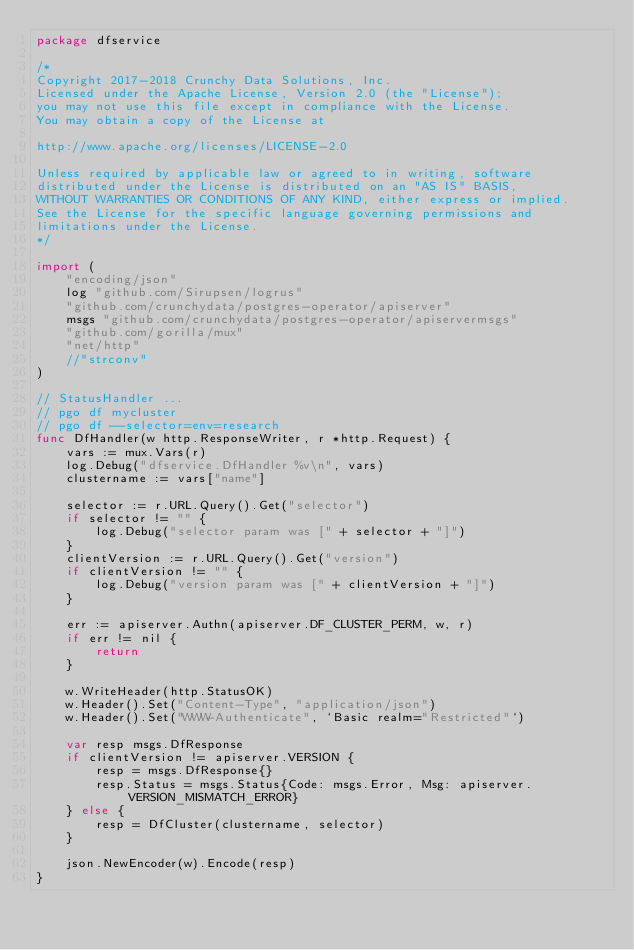<code> <loc_0><loc_0><loc_500><loc_500><_Go_>package dfservice

/*
Copyright 2017-2018 Crunchy Data Solutions, Inc.
Licensed under the Apache License, Version 2.0 (the "License");
you may not use this file except in compliance with the License.
You may obtain a copy of the License at

http://www.apache.org/licenses/LICENSE-2.0

Unless required by applicable law or agreed to in writing, software
distributed under the License is distributed on an "AS IS" BASIS,
WITHOUT WARRANTIES OR CONDITIONS OF ANY KIND, either express or implied.
See the License for the specific language governing permissions and
limitations under the License.
*/

import (
	"encoding/json"
	log "github.com/Sirupsen/logrus"
	"github.com/crunchydata/postgres-operator/apiserver"
	msgs "github.com/crunchydata/postgres-operator/apiservermsgs"
	"github.com/gorilla/mux"
	"net/http"
	//"strconv"
)

// StatusHandler ...
// pgo df mycluster
// pgo df --selector=env=research
func DfHandler(w http.ResponseWriter, r *http.Request) {
	vars := mux.Vars(r)
	log.Debug("dfservice.DfHandler %v\n", vars)
	clustername := vars["name"]

	selector := r.URL.Query().Get("selector")
	if selector != "" {
		log.Debug("selector param was [" + selector + "]")
	}
	clientVersion := r.URL.Query().Get("version")
	if clientVersion != "" {
		log.Debug("version param was [" + clientVersion + "]")
	}

	err := apiserver.Authn(apiserver.DF_CLUSTER_PERM, w, r)
	if err != nil {
		return
	}

	w.WriteHeader(http.StatusOK)
	w.Header().Set("Content-Type", "application/json")
	w.Header().Set("WWW-Authenticate", `Basic realm="Restricted"`)

	var resp msgs.DfResponse
	if clientVersion != apiserver.VERSION {
		resp = msgs.DfResponse{}
		resp.Status = msgs.Status{Code: msgs.Error, Msg: apiserver.VERSION_MISMATCH_ERROR}
	} else {
		resp = DfCluster(clustername, selector)
	}

	json.NewEncoder(w).Encode(resp)
}
</code> 